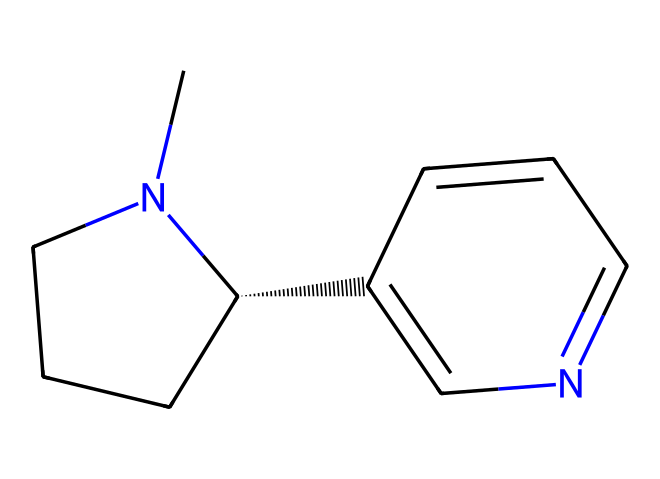How many rings are present in the nicotine structure? The structural formula of nicotine shows two rings: one is a five-membered ring (the piperidine) and the other is a six-membered ring (the pyridine). By visual inspection, you can count the rings directly in the SMILES representation.
Answer: 2 What is the total number of nitrogen atoms in nicotine? In the structure of nicotine, there are two nitrogen atoms present. You can identify nitrogen by looking for 'N' in the chemical structure.
Answer: 2 Which functional groups are present in the nicotine molecule? The nicotine molecule contains an alkaloid functional group due to the presence of nitrogen atoms in its cyclic structure, which contributes to its pharmacological effects. The presence of these nitrogen atoms indicates the alkaloid classification.
Answer: alkaloid What type of chemical compound is nicotine categorized as? Nicotine is classified as an alkaloid, which is a type of medicinal compound derived from plants. The basic definition implies that it contains basic nitrogen atoms and has significant pharmacological effects.
Answer: alkaloid What molecular feature gives nicotine its biological activity? The presence of the basic nitrogen atom in the cyclic structure of nicotine is what contributes to its ability to interact with biological receptors, impacting neuromodulation and addiction potential.
Answer: nitrogen atom 